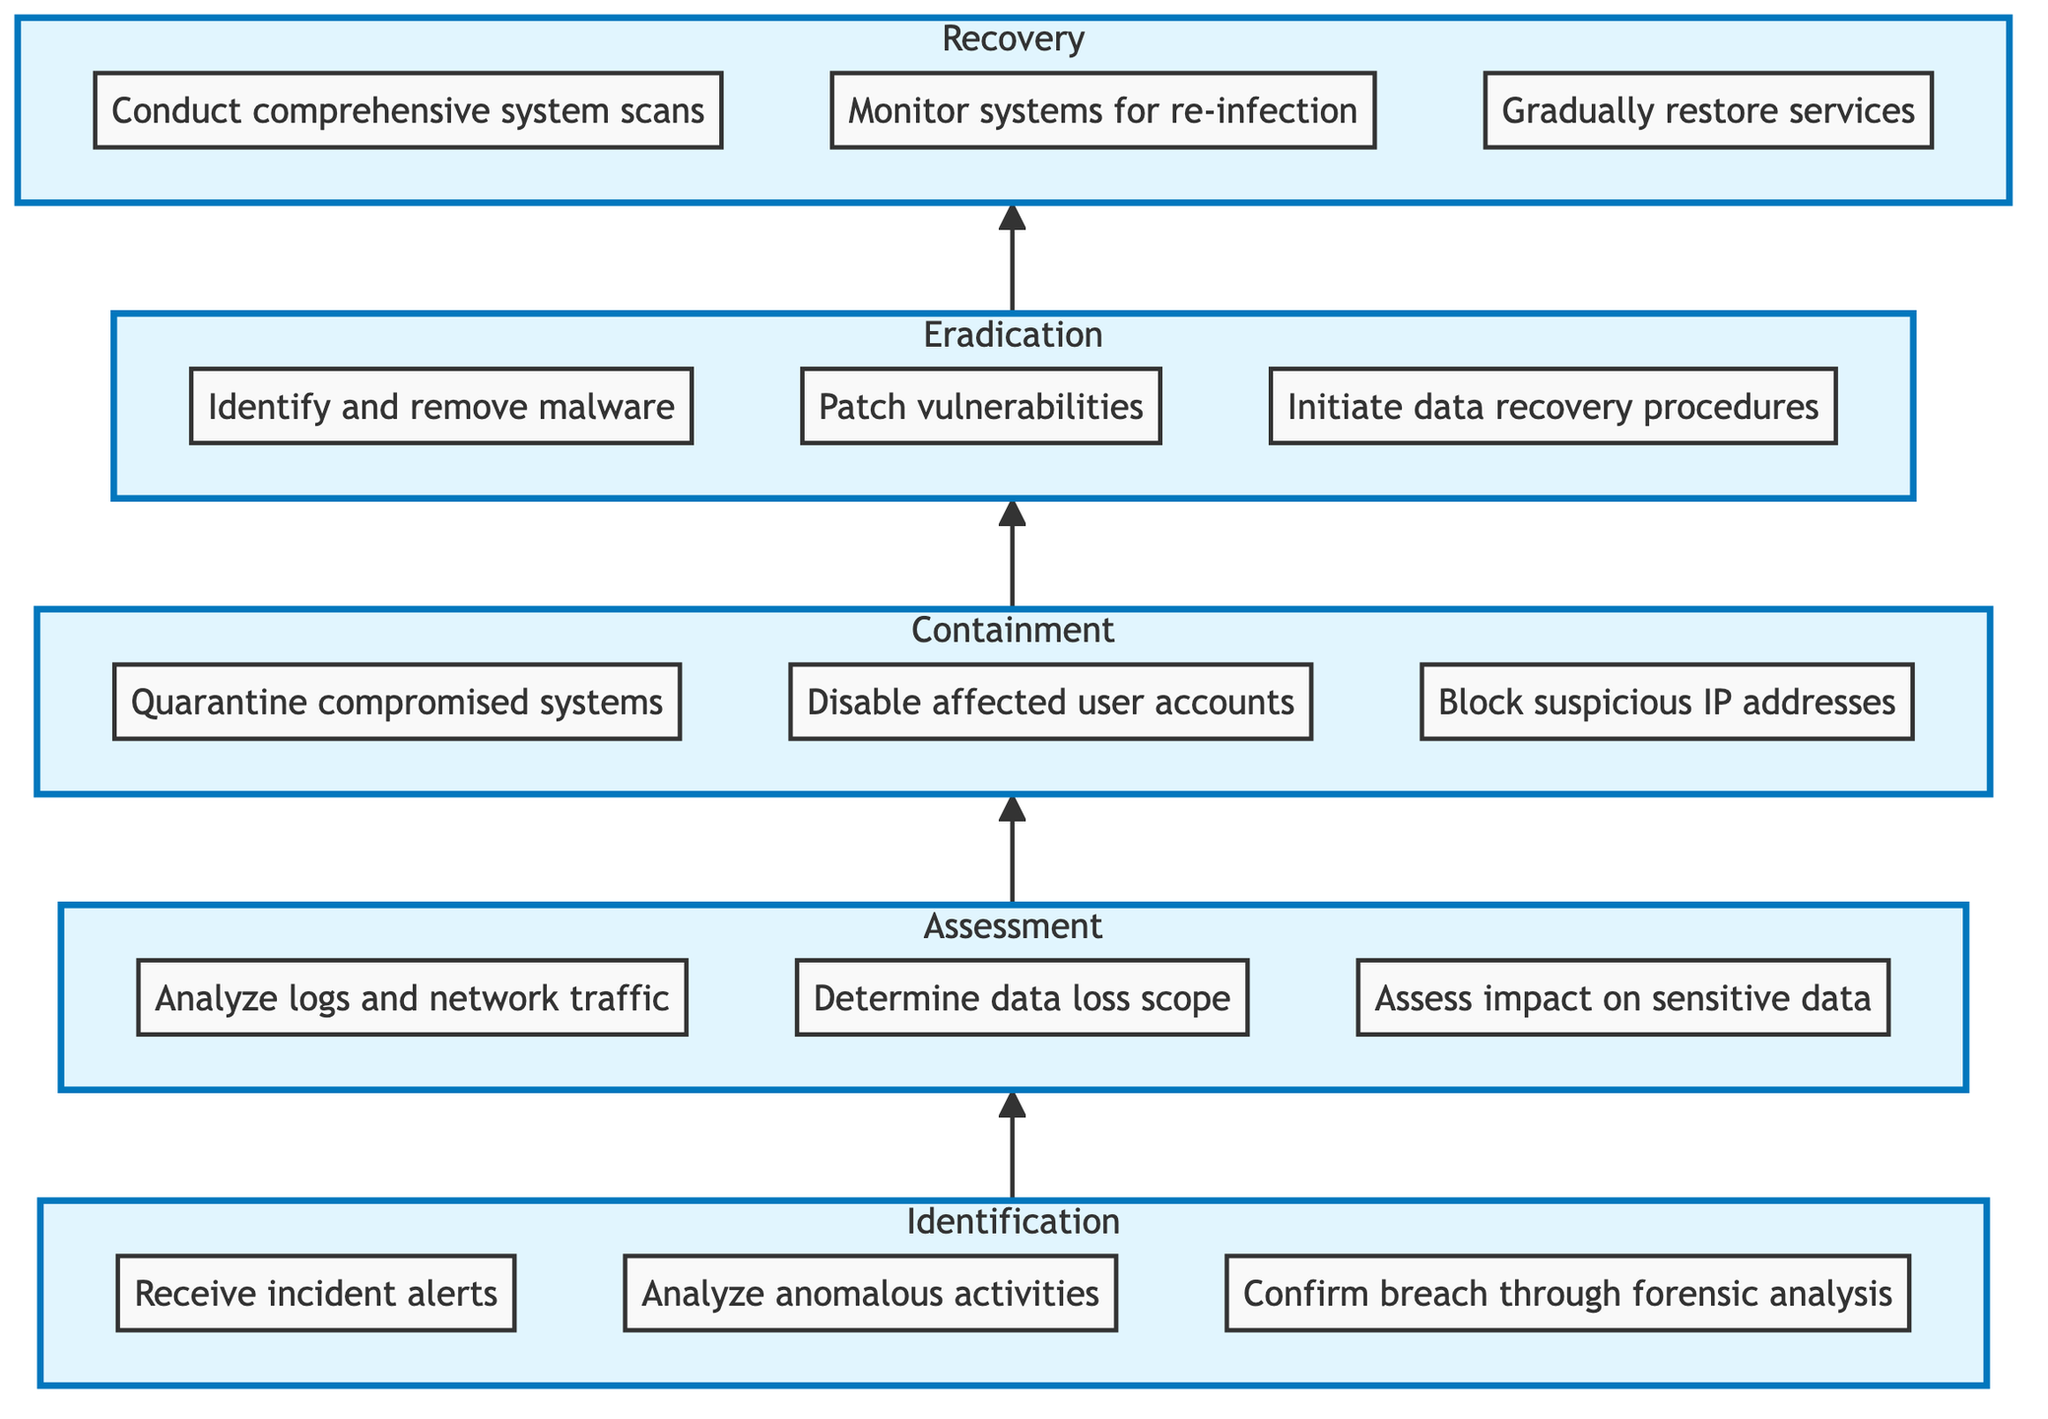What is the first step in the protocol? The first step is "Receive incident alerts" under the "Identification" section. This is where the process begins, as it signifies the detection of a potential breach.
Answer: Receive incident alerts How many total steps are there in the diagram? To find the total steps, we can count each individual step in all sections: Identification (3), Assessment (3), Containment (3), Eradication (3), and Recovery (3), which totals to 15 steps.
Answer: 15 Which step follows after "Analyze anomalous activities"? After "Analyze anomalous activities," the next step in the protocol is "Confirm breach through forensic analysis," which is part of the Identification section.
Answer: Confirm breach through forensic analysis What are the steps involved in the "Containment" process? The steps involved in the "Containment" process include "Quarantine compromised systems," "Disable affected user accounts," and "Block suspicious IP addresses." These steps focus on isolating the affected systems.
Answer: Quarantine compromised systems, Disable affected user accounts, Block suspicious IP addresses What is the last phase of the data breach protocol? The last phase of the protocol is "Recovery." This is where systems are validated and normal operations are resumed.
Answer: Recovery Which nodes are connected to the "Assessment" step? The "Assessment" step connects to the "Containment" step directly above it in the flow. Additionally, it is fed by the "Identification" step directly below it, emphasizing the flow of actions from identifying the breach to evaluating its impact.
Answer: Containment What is the relationship between "Eradication" and "Recovery"? "Eradication" occurs directly before "Recovery" in the sequence, indicating that systems must be cleaned and restored before normal operations can resume. Thus, Recovery cannot occur without Eradication being completed first.
Answer: Eradication precedes Recovery How many nodes are in the "Eradication" section? There are three nodes in the "Eradication" section: "Identify and remove malware," "Patch vulnerabilities," and "Initiate data recovery procedures." Each node represents a critical step in eliminating the breach.
Answer: 3 nodes 